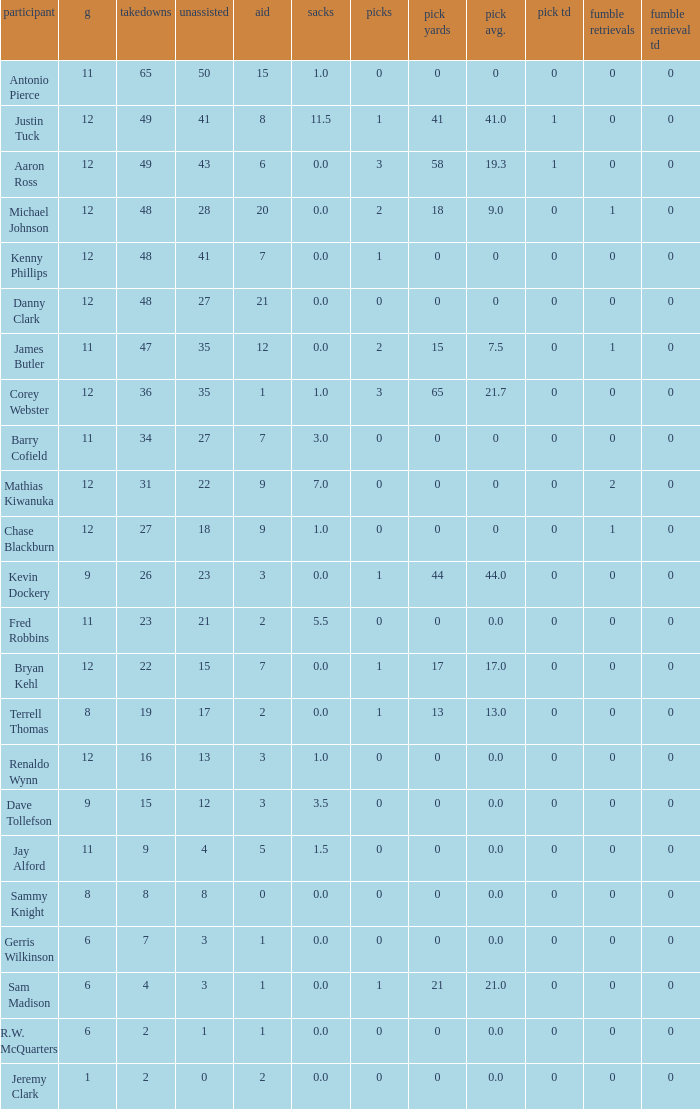Specify the minimal quantity of whole yards. 0.0. 